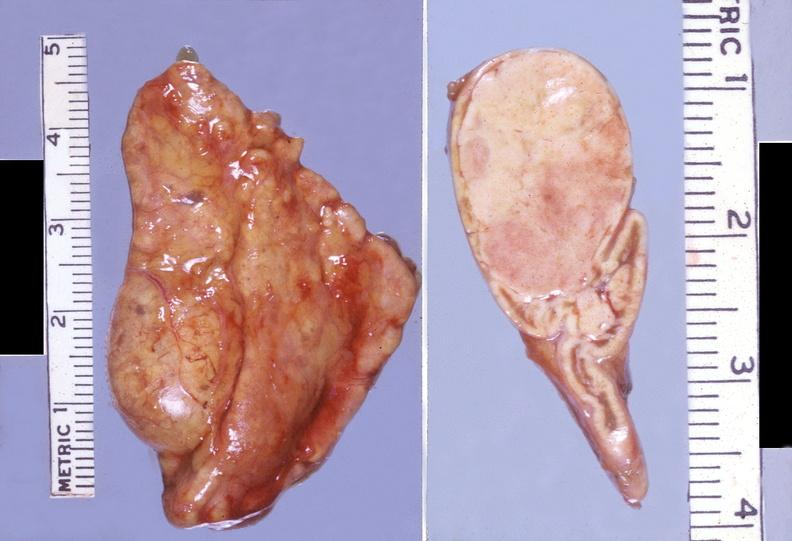where does this belong to?
Answer the question using a single word or phrase. Endocrine system 